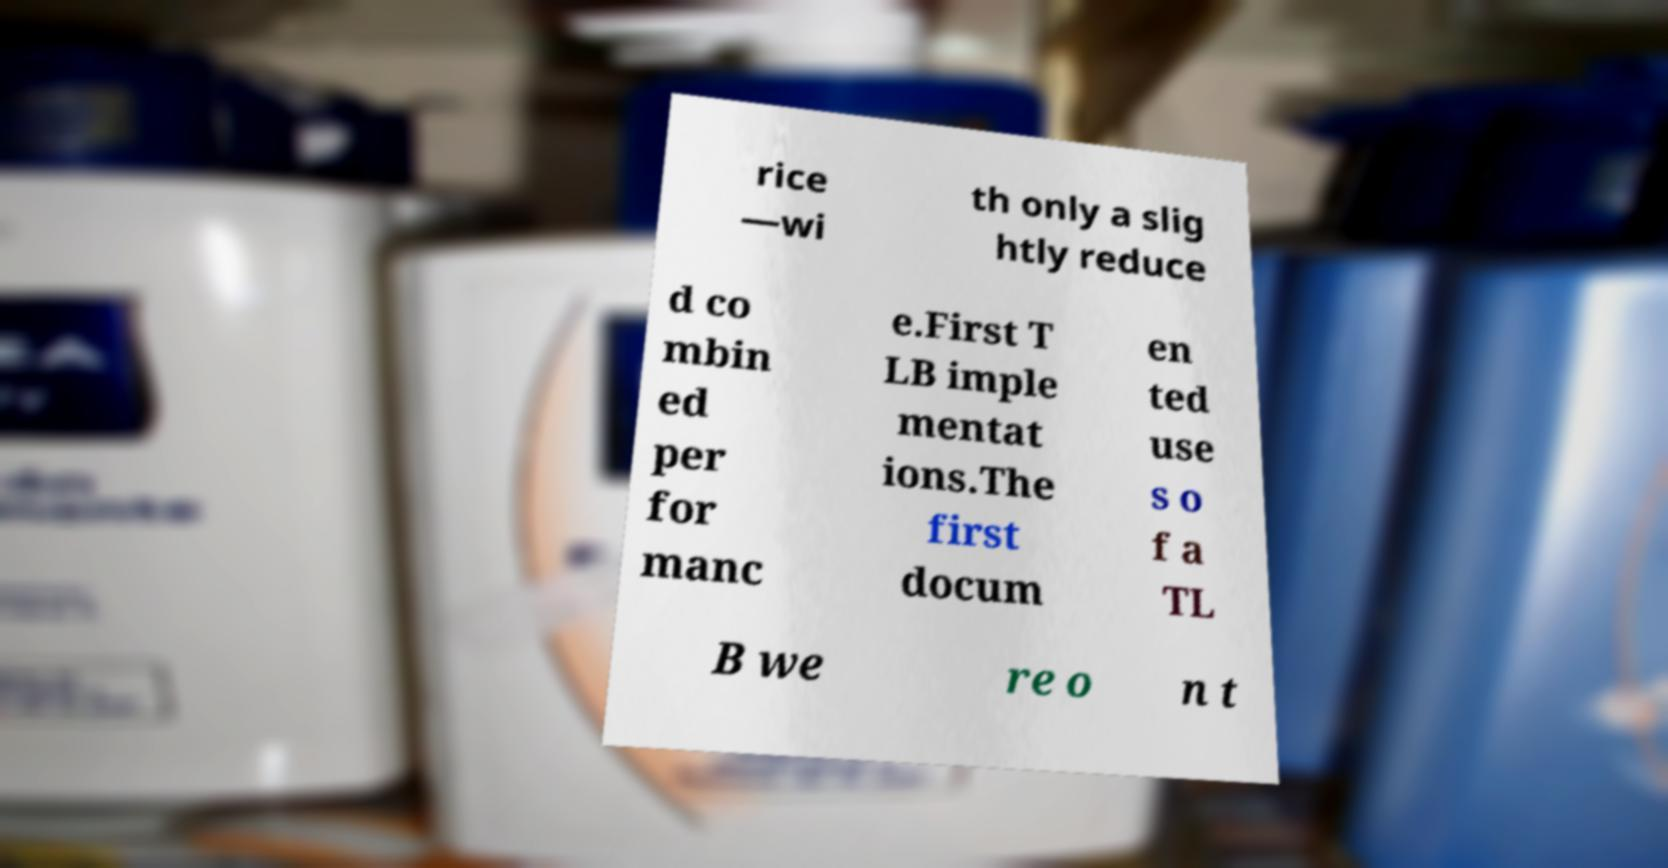I need the written content from this picture converted into text. Can you do that? rice —wi th only a slig htly reduce d co mbin ed per for manc e.First T LB imple mentat ions.The first docum en ted use s o f a TL B we re o n t 